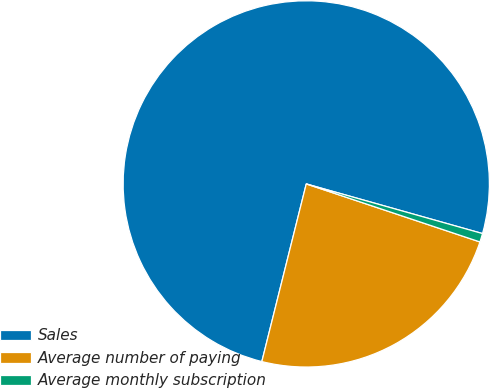<chart> <loc_0><loc_0><loc_500><loc_500><pie_chart><fcel>Sales<fcel>Average number of paying<fcel>Average monthly subscription<nl><fcel>75.47%<fcel>23.77%<fcel>0.76%<nl></chart> 